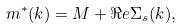<formula> <loc_0><loc_0><loc_500><loc_500>m ^ { * } ( k ) = M + \Re e \Sigma _ { s } ( k ) ,</formula> 